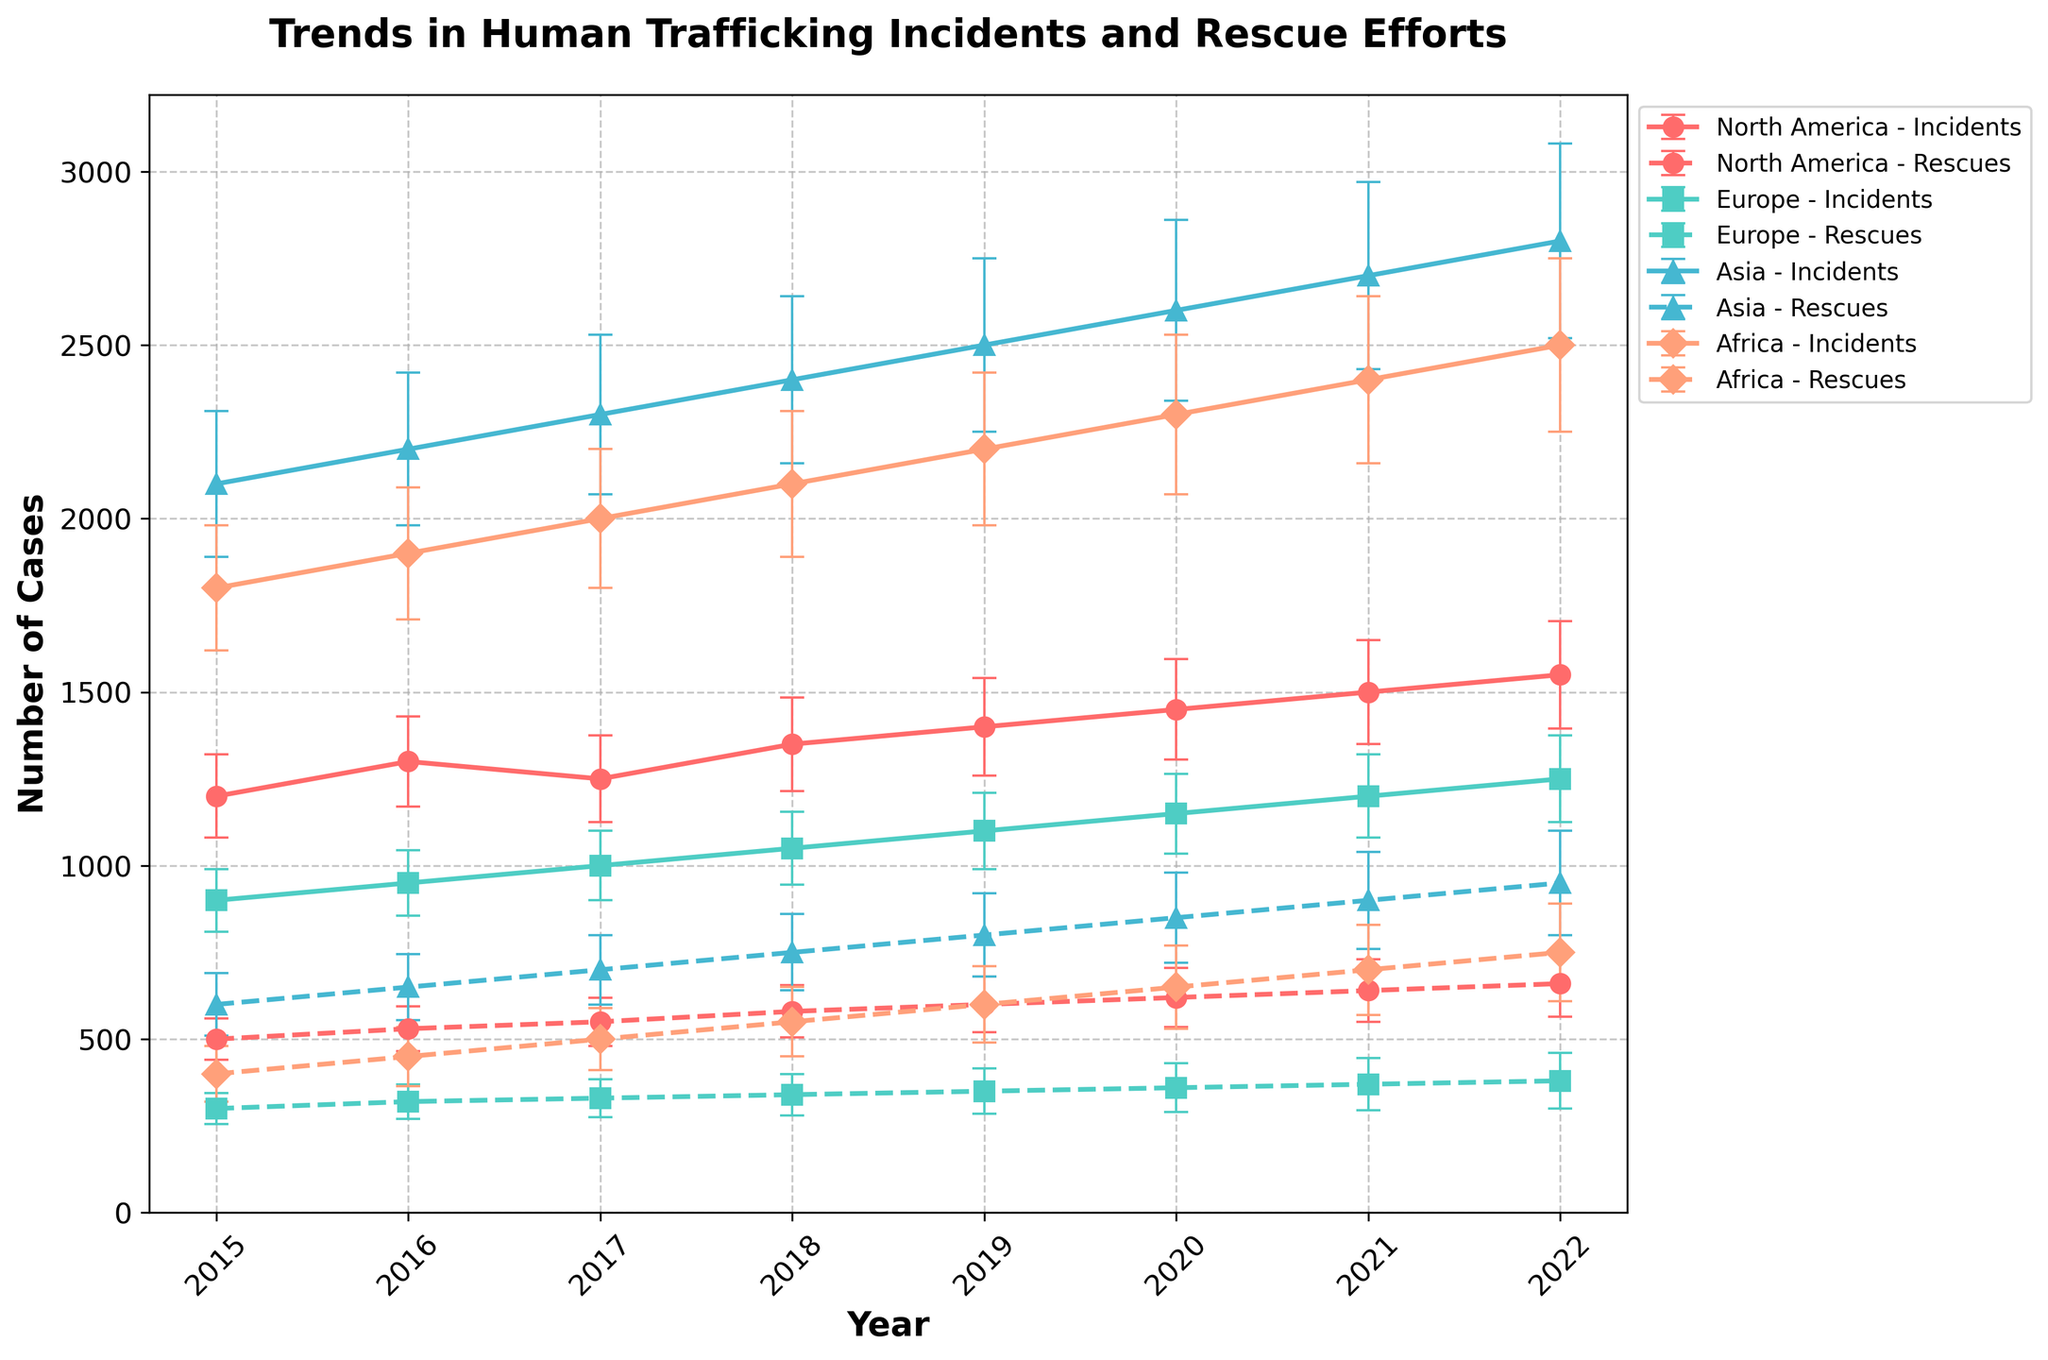What's the title of the figure? The title is typically at the top of the figure and is presented as "Trends in Human Trafficking Incidents and Rescue Efforts".
Answer: Trends in Human Trafficking Incidents and Rescue Efforts Which region had the highest number of reported incidents in 2022? By examining the highest data point on the events lines in 2022, you see that Asia had the highest number of reported incidents.
Answer: Asia What pattern is observed in the number of reported incidents in North America over the years? Trace the line for reported incidents in North America from 2015 to 2022. You will notice a rising trend.
Answer: Increasing trend What was the number of rescued individuals in Europe in 2017, and what was the uncertainty? Follow the 2017 marker for Europe on the rescue efforts line; it shows 330 rescued individuals with an uncertainty indicated by the error bar of ±55.
Answer: 330 rescued, ±55 uncertainty How did the number of rescued individuals change in Asia from 2015 to 2022? Compare the number of rescued individuals in Asia in 2015 and 2022 by looking at the endpoints of the rescue efforts line for Asia: 600 in 2015 and 950 in 2022.
Answer: Increased by 350 Which region shows a consistent increase in the number of both reported incidents and rescued individuals from 2015 to 2022? Observe the trends for both incidents and rescues. North America shows a consistent increase in both metrics from 2015 to 2022.
Answer: North America By how much did the number of reported incidents decrease in Europe between 2019 and 2020? Check the reported incidents in Europe for 2019 and 2020, which are 1100 and 1150 respectively. Subtract the two values (1150 - 1100).
Answer: Decreased by 50 Which year did Africa see the highest number of rescued individuals? Identify the peak on the rescue efforts line for Africa, which is in 2022.
Answer: 2022 What is the relationship between reported incidents and rescued individuals in Asia in 2021? Compare the data points for reported incidents (2700) and rescued individuals (900) in 2021; the number of incidents is three times the rescues.
Answer: Incidents are three times rescues Which year and region had the smallest number of rescued individuals, and what was the number? Find the lowest value on the rescue efforts lines, which is for Europe in 2015, with 300 rescued individuals.
Answer: Europe, 2015, 300 